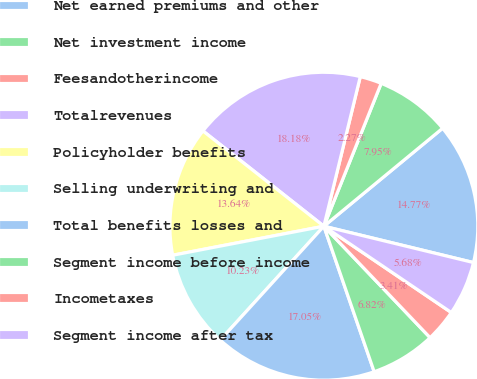Convert chart to OTSL. <chart><loc_0><loc_0><loc_500><loc_500><pie_chart><fcel>Net earned premiums and other<fcel>Net investment income<fcel>Feesandotherincome<fcel>Totalrevenues<fcel>Policyholder benefits<fcel>Selling underwriting and<fcel>Total benefits losses and<fcel>Segment income before income<fcel>Incometaxes<fcel>Segment income after tax<nl><fcel>14.77%<fcel>7.95%<fcel>2.27%<fcel>18.18%<fcel>13.64%<fcel>10.23%<fcel>17.05%<fcel>6.82%<fcel>3.41%<fcel>5.68%<nl></chart> 